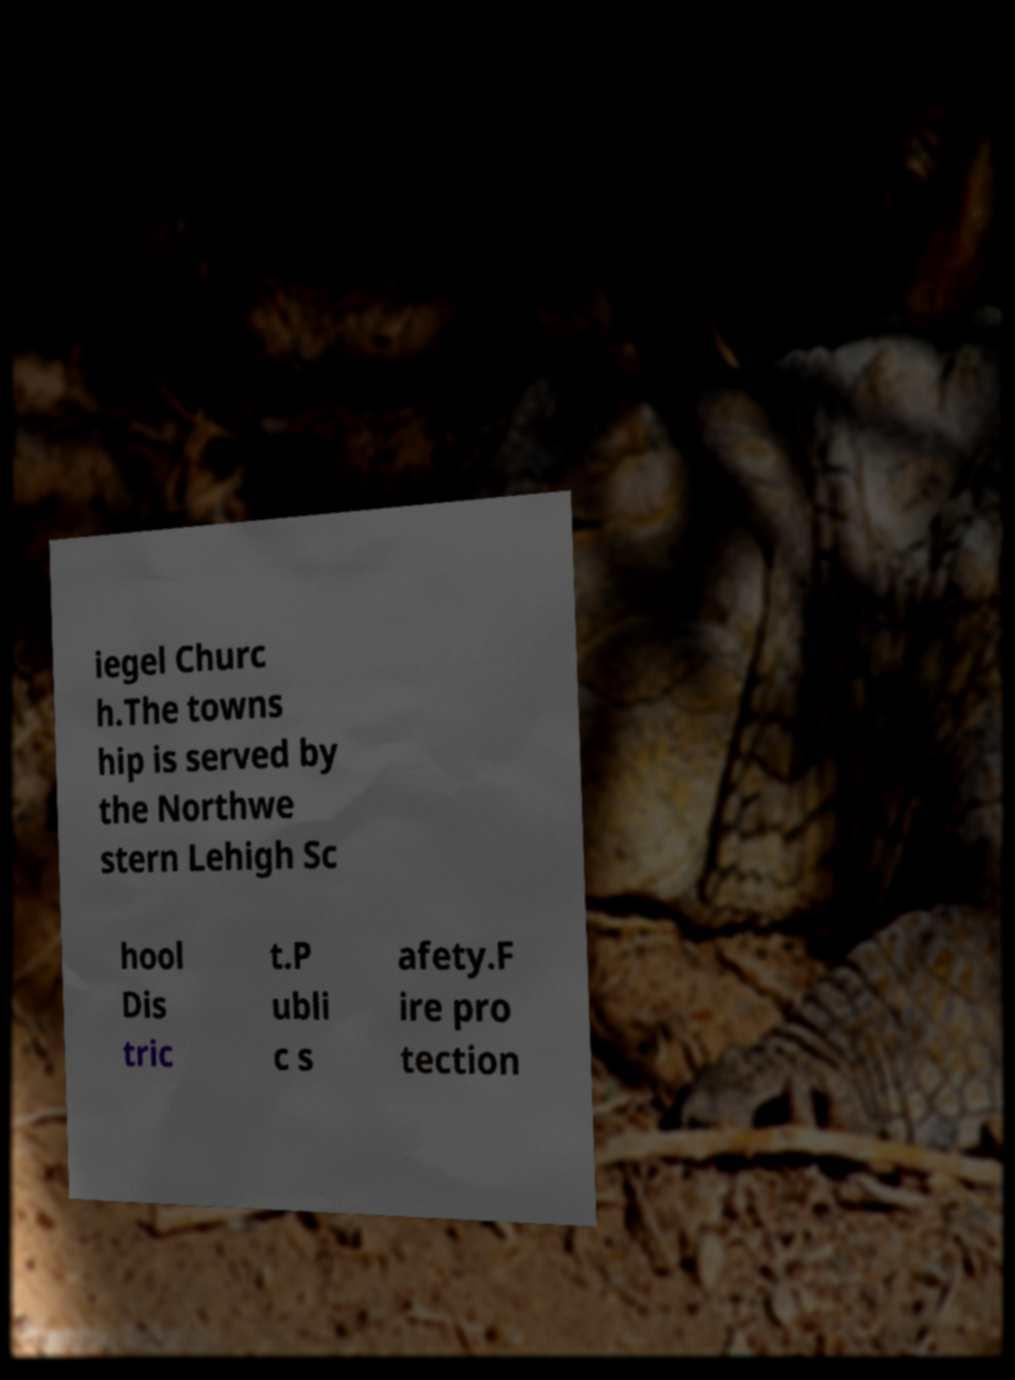Please identify and transcribe the text found in this image. iegel Churc h.The towns hip is served by the Northwe stern Lehigh Sc hool Dis tric t.P ubli c s afety.F ire pro tection 